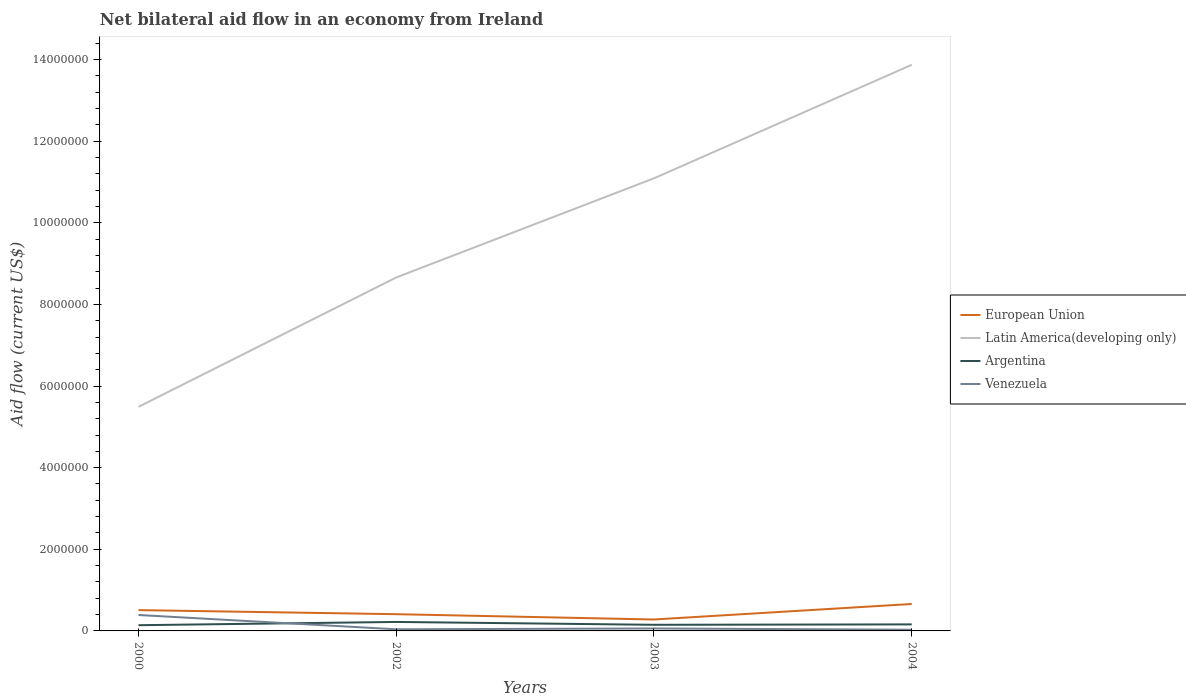In which year was the net bilateral aid flow in Venezuela maximum?
Keep it short and to the point. 2004. What is the difference between the highest and the second highest net bilateral aid flow in Argentina?
Give a very brief answer. 8.00e+04. How many lines are there?
Your answer should be compact. 4. Does the graph contain any zero values?
Your answer should be very brief. No. How many legend labels are there?
Offer a very short reply. 4. What is the title of the graph?
Make the answer very short. Net bilateral aid flow in an economy from Ireland. Does "East Asia (developing only)" appear as one of the legend labels in the graph?
Offer a terse response. No. What is the Aid flow (current US$) of European Union in 2000?
Give a very brief answer. 5.10e+05. What is the Aid flow (current US$) of Latin America(developing only) in 2000?
Give a very brief answer. 5.49e+06. What is the Aid flow (current US$) in Argentina in 2000?
Make the answer very short. 1.40e+05. What is the Aid flow (current US$) of European Union in 2002?
Ensure brevity in your answer.  4.10e+05. What is the Aid flow (current US$) in Latin America(developing only) in 2002?
Your answer should be compact. 8.66e+06. What is the Aid flow (current US$) of Argentina in 2002?
Keep it short and to the point. 2.20e+05. What is the Aid flow (current US$) of Latin America(developing only) in 2003?
Your answer should be very brief. 1.11e+07. What is the Aid flow (current US$) of Argentina in 2003?
Your answer should be very brief. 1.50e+05. What is the Aid flow (current US$) in Venezuela in 2003?
Your response must be concise. 6.00e+04. What is the Aid flow (current US$) of European Union in 2004?
Offer a very short reply. 6.60e+05. What is the Aid flow (current US$) of Latin America(developing only) in 2004?
Provide a succinct answer. 1.39e+07. Across all years, what is the maximum Aid flow (current US$) in European Union?
Provide a short and direct response. 6.60e+05. Across all years, what is the maximum Aid flow (current US$) in Latin America(developing only)?
Give a very brief answer. 1.39e+07. Across all years, what is the maximum Aid flow (current US$) of Venezuela?
Keep it short and to the point. 3.90e+05. Across all years, what is the minimum Aid flow (current US$) of European Union?
Offer a very short reply. 2.80e+05. Across all years, what is the minimum Aid flow (current US$) in Latin America(developing only)?
Provide a short and direct response. 5.49e+06. Across all years, what is the minimum Aid flow (current US$) in Venezuela?
Your answer should be compact. 3.00e+04. What is the total Aid flow (current US$) in European Union in the graph?
Give a very brief answer. 1.86e+06. What is the total Aid flow (current US$) in Latin America(developing only) in the graph?
Make the answer very short. 3.91e+07. What is the total Aid flow (current US$) of Argentina in the graph?
Your answer should be compact. 6.70e+05. What is the total Aid flow (current US$) in Venezuela in the graph?
Your response must be concise. 5.20e+05. What is the difference between the Aid flow (current US$) of European Union in 2000 and that in 2002?
Give a very brief answer. 1.00e+05. What is the difference between the Aid flow (current US$) in Latin America(developing only) in 2000 and that in 2002?
Keep it short and to the point. -3.17e+06. What is the difference between the Aid flow (current US$) in Venezuela in 2000 and that in 2002?
Offer a very short reply. 3.50e+05. What is the difference between the Aid flow (current US$) of European Union in 2000 and that in 2003?
Offer a very short reply. 2.30e+05. What is the difference between the Aid flow (current US$) of Latin America(developing only) in 2000 and that in 2003?
Your response must be concise. -5.60e+06. What is the difference between the Aid flow (current US$) of European Union in 2000 and that in 2004?
Offer a terse response. -1.50e+05. What is the difference between the Aid flow (current US$) in Latin America(developing only) in 2000 and that in 2004?
Provide a short and direct response. -8.38e+06. What is the difference between the Aid flow (current US$) of Argentina in 2000 and that in 2004?
Provide a short and direct response. -2.00e+04. What is the difference between the Aid flow (current US$) in Latin America(developing only) in 2002 and that in 2003?
Your answer should be compact. -2.43e+06. What is the difference between the Aid flow (current US$) of Venezuela in 2002 and that in 2003?
Your answer should be very brief. -2.00e+04. What is the difference between the Aid flow (current US$) in Latin America(developing only) in 2002 and that in 2004?
Offer a terse response. -5.21e+06. What is the difference between the Aid flow (current US$) in Argentina in 2002 and that in 2004?
Make the answer very short. 6.00e+04. What is the difference between the Aid flow (current US$) in Venezuela in 2002 and that in 2004?
Give a very brief answer. 10000. What is the difference between the Aid flow (current US$) in European Union in 2003 and that in 2004?
Offer a very short reply. -3.80e+05. What is the difference between the Aid flow (current US$) of Latin America(developing only) in 2003 and that in 2004?
Give a very brief answer. -2.78e+06. What is the difference between the Aid flow (current US$) of Argentina in 2003 and that in 2004?
Offer a terse response. -10000. What is the difference between the Aid flow (current US$) of European Union in 2000 and the Aid flow (current US$) of Latin America(developing only) in 2002?
Ensure brevity in your answer.  -8.15e+06. What is the difference between the Aid flow (current US$) of Latin America(developing only) in 2000 and the Aid flow (current US$) of Argentina in 2002?
Offer a very short reply. 5.27e+06. What is the difference between the Aid flow (current US$) in Latin America(developing only) in 2000 and the Aid flow (current US$) in Venezuela in 2002?
Keep it short and to the point. 5.45e+06. What is the difference between the Aid flow (current US$) of Argentina in 2000 and the Aid flow (current US$) of Venezuela in 2002?
Keep it short and to the point. 1.00e+05. What is the difference between the Aid flow (current US$) in European Union in 2000 and the Aid flow (current US$) in Latin America(developing only) in 2003?
Make the answer very short. -1.06e+07. What is the difference between the Aid flow (current US$) in European Union in 2000 and the Aid flow (current US$) in Argentina in 2003?
Give a very brief answer. 3.60e+05. What is the difference between the Aid flow (current US$) in Latin America(developing only) in 2000 and the Aid flow (current US$) in Argentina in 2003?
Ensure brevity in your answer.  5.34e+06. What is the difference between the Aid flow (current US$) in Latin America(developing only) in 2000 and the Aid flow (current US$) in Venezuela in 2003?
Ensure brevity in your answer.  5.43e+06. What is the difference between the Aid flow (current US$) of European Union in 2000 and the Aid flow (current US$) of Latin America(developing only) in 2004?
Provide a short and direct response. -1.34e+07. What is the difference between the Aid flow (current US$) in European Union in 2000 and the Aid flow (current US$) in Argentina in 2004?
Your answer should be compact. 3.50e+05. What is the difference between the Aid flow (current US$) in European Union in 2000 and the Aid flow (current US$) in Venezuela in 2004?
Your answer should be very brief. 4.80e+05. What is the difference between the Aid flow (current US$) of Latin America(developing only) in 2000 and the Aid flow (current US$) of Argentina in 2004?
Your answer should be compact. 5.33e+06. What is the difference between the Aid flow (current US$) of Latin America(developing only) in 2000 and the Aid flow (current US$) of Venezuela in 2004?
Provide a succinct answer. 5.46e+06. What is the difference between the Aid flow (current US$) in European Union in 2002 and the Aid flow (current US$) in Latin America(developing only) in 2003?
Give a very brief answer. -1.07e+07. What is the difference between the Aid flow (current US$) of Latin America(developing only) in 2002 and the Aid flow (current US$) of Argentina in 2003?
Give a very brief answer. 8.51e+06. What is the difference between the Aid flow (current US$) of Latin America(developing only) in 2002 and the Aid flow (current US$) of Venezuela in 2003?
Keep it short and to the point. 8.60e+06. What is the difference between the Aid flow (current US$) of Argentina in 2002 and the Aid flow (current US$) of Venezuela in 2003?
Offer a terse response. 1.60e+05. What is the difference between the Aid flow (current US$) in European Union in 2002 and the Aid flow (current US$) in Latin America(developing only) in 2004?
Ensure brevity in your answer.  -1.35e+07. What is the difference between the Aid flow (current US$) of European Union in 2002 and the Aid flow (current US$) of Argentina in 2004?
Offer a very short reply. 2.50e+05. What is the difference between the Aid flow (current US$) in European Union in 2002 and the Aid flow (current US$) in Venezuela in 2004?
Provide a short and direct response. 3.80e+05. What is the difference between the Aid flow (current US$) of Latin America(developing only) in 2002 and the Aid flow (current US$) of Argentina in 2004?
Keep it short and to the point. 8.50e+06. What is the difference between the Aid flow (current US$) in Latin America(developing only) in 2002 and the Aid flow (current US$) in Venezuela in 2004?
Your response must be concise. 8.63e+06. What is the difference between the Aid flow (current US$) in European Union in 2003 and the Aid flow (current US$) in Latin America(developing only) in 2004?
Give a very brief answer. -1.36e+07. What is the difference between the Aid flow (current US$) in Latin America(developing only) in 2003 and the Aid flow (current US$) in Argentina in 2004?
Your answer should be compact. 1.09e+07. What is the difference between the Aid flow (current US$) in Latin America(developing only) in 2003 and the Aid flow (current US$) in Venezuela in 2004?
Your answer should be very brief. 1.11e+07. What is the difference between the Aid flow (current US$) of Argentina in 2003 and the Aid flow (current US$) of Venezuela in 2004?
Offer a terse response. 1.20e+05. What is the average Aid flow (current US$) in European Union per year?
Your answer should be compact. 4.65e+05. What is the average Aid flow (current US$) of Latin America(developing only) per year?
Make the answer very short. 9.78e+06. What is the average Aid flow (current US$) of Argentina per year?
Ensure brevity in your answer.  1.68e+05. In the year 2000, what is the difference between the Aid flow (current US$) in European Union and Aid flow (current US$) in Latin America(developing only)?
Your answer should be very brief. -4.98e+06. In the year 2000, what is the difference between the Aid flow (current US$) of European Union and Aid flow (current US$) of Venezuela?
Ensure brevity in your answer.  1.20e+05. In the year 2000, what is the difference between the Aid flow (current US$) in Latin America(developing only) and Aid flow (current US$) in Argentina?
Offer a terse response. 5.35e+06. In the year 2000, what is the difference between the Aid flow (current US$) of Latin America(developing only) and Aid flow (current US$) of Venezuela?
Your answer should be very brief. 5.10e+06. In the year 2002, what is the difference between the Aid flow (current US$) in European Union and Aid flow (current US$) in Latin America(developing only)?
Your answer should be very brief. -8.25e+06. In the year 2002, what is the difference between the Aid flow (current US$) in European Union and Aid flow (current US$) in Argentina?
Keep it short and to the point. 1.90e+05. In the year 2002, what is the difference between the Aid flow (current US$) of Latin America(developing only) and Aid flow (current US$) of Argentina?
Your answer should be compact. 8.44e+06. In the year 2002, what is the difference between the Aid flow (current US$) of Latin America(developing only) and Aid flow (current US$) of Venezuela?
Give a very brief answer. 8.62e+06. In the year 2002, what is the difference between the Aid flow (current US$) in Argentina and Aid flow (current US$) in Venezuela?
Offer a very short reply. 1.80e+05. In the year 2003, what is the difference between the Aid flow (current US$) in European Union and Aid flow (current US$) in Latin America(developing only)?
Provide a short and direct response. -1.08e+07. In the year 2003, what is the difference between the Aid flow (current US$) in European Union and Aid flow (current US$) in Venezuela?
Your answer should be very brief. 2.20e+05. In the year 2003, what is the difference between the Aid flow (current US$) in Latin America(developing only) and Aid flow (current US$) in Argentina?
Make the answer very short. 1.09e+07. In the year 2003, what is the difference between the Aid flow (current US$) in Latin America(developing only) and Aid flow (current US$) in Venezuela?
Keep it short and to the point. 1.10e+07. In the year 2004, what is the difference between the Aid flow (current US$) in European Union and Aid flow (current US$) in Latin America(developing only)?
Your answer should be very brief. -1.32e+07. In the year 2004, what is the difference between the Aid flow (current US$) of European Union and Aid flow (current US$) of Argentina?
Provide a short and direct response. 5.00e+05. In the year 2004, what is the difference between the Aid flow (current US$) of European Union and Aid flow (current US$) of Venezuela?
Your answer should be very brief. 6.30e+05. In the year 2004, what is the difference between the Aid flow (current US$) in Latin America(developing only) and Aid flow (current US$) in Argentina?
Offer a very short reply. 1.37e+07. In the year 2004, what is the difference between the Aid flow (current US$) in Latin America(developing only) and Aid flow (current US$) in Venezuela?
Your answer should be very brief. 1.38e+07. What is the ratio of the Aid flow (current US$) in European Union in 2000 to that in 2002?
Make the answer very short. 1.24. What is the ratio of the Aid flow (current US$) in Latin America(developing only) in 2000 to that in 2002?
Offer a very short reply. 0.63. What is the ratio of the Aid flow (current US$) of Argentina in 2000 to that in 2002?
Keep it short and to the point. 0.64. What is the ratio of the Aid flow (current US$) of Venezuela in 2000 to that in 2002?
Give a very brief answer. 9.75. What is the ratio of the Aid flow (current US$) in European Union in 2000 to that in 2003?
Give a very brief answer. 1.82. What is the ratio of the Aid flow (current US$) in Latin America(developing only) in 2000 to that in 2003?
Ensure brevity in your answer.  0.49. What is the ratio of the Aid flow (current US$) of European Union in 2000 to that in 2004?
Your answer should be compact. 0.77. What is the ratio of the Aid flow (current US$) of Latin America(developing only) in 2000 to that in 2004?
Keep it short and to the point. 0.4. What is the ratio of the Aid flow (current US$) in Argentina in 2000 to that in 2004?
Provide a short and direct response. 0.88. What is the ratio of the Aid flow (current US$) in Venezuela in 2000 to that in 2004?
Your answer should be compact. 13. What is the ratio of the Aid flow (current US$) of European Union in 2002 to that in 2003?
Provide a short and direct response. 1.46. What is the ratio of the Aid flow (current US$) in Latin America(developing only) in 2002 to that in 2003?
Your answer should be compact. 0.78. What is the ratio of the Aid flow (current US$) of Argentina in 2002 to that in 2003?
Ensure brevity in your answer.  1.47. What is the ratio of the Aid flow (current US$) in Venezuela in 2002 to that in 2003?
Give a very brief answer. 0.67. What is the ratio of the Aid flow (current US$) in European Union in 2002 to that in 2004?
Make the answer very short. 0.62. What is the ratio of the Aid flow (current US$) of Latin America(developing only) in 2002 to that in 2004?
Provide a short and direct response. 0.62. What is the ratio of the Aid flow (current US$) in Argentina in 2002 to that in 2004?
Keep it short and to the point. 1.38. What is the ratio of the Aid flow (current US$) of European Union in 2003 to that in 2004?
Your response must be concise. 0.42. What is the ratio of the Aid flow (current US$) in Latin America(developing only) in 2003 to that in 2004?
Give a very brief answer. 0.8. What is the difference between the highest and the second highest Aid flow (current US$) of European Union?
Offer a terse response. 1.50e+05. What is the difference between the highest and the second highest Aid flow (current US$) of Latin America(developing only)?
Provide a succinct answer. 2.78e+06. What is the difference between the highest and the lowest Aid flow (current US$) in European Union?
Provide a short and direct response. 3.80e+05. What is the difference between the highest and the lowest Aid flow (current US$) in Latin America(developing only)?
Make the answer very short. 8.38e+06. What is the difference between the highest and the lowest Aid flow (current US$) of Venezuela?
Your answer should be very brief. 3.60e+05. 